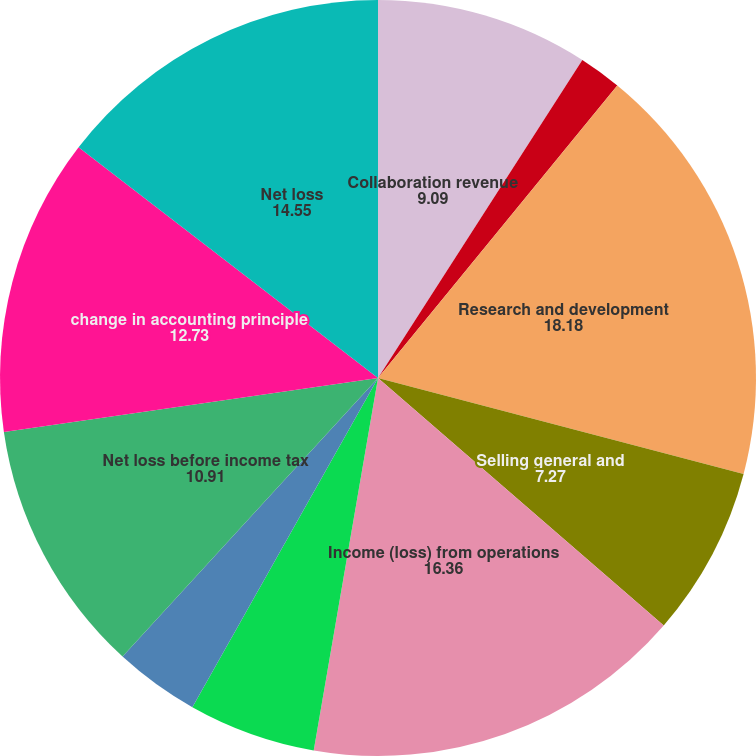Convert chart. <chart><loc_0><loc_0><loc_500><loc_500><pie_chart><fcel>Collaboration revenue<fcel>Contract research and other<fcel>Research and development<fcel>Selling general and<fcel>Income (loss) from operations<fcel>Investment income<fcel>Interest expense<fcel>Net loss before income tax<fcel>change in accounting principle<fcel>Net loss<nl><fcel>9.09%<fcel>1.82%<fcel>18.18%<fcel>7.27%<fcel>16.36%<fcel>5.45%<fcel>3.64%<fcel>10.91%<fcel>12.73%<fcel>14.55%<nl></chart> 